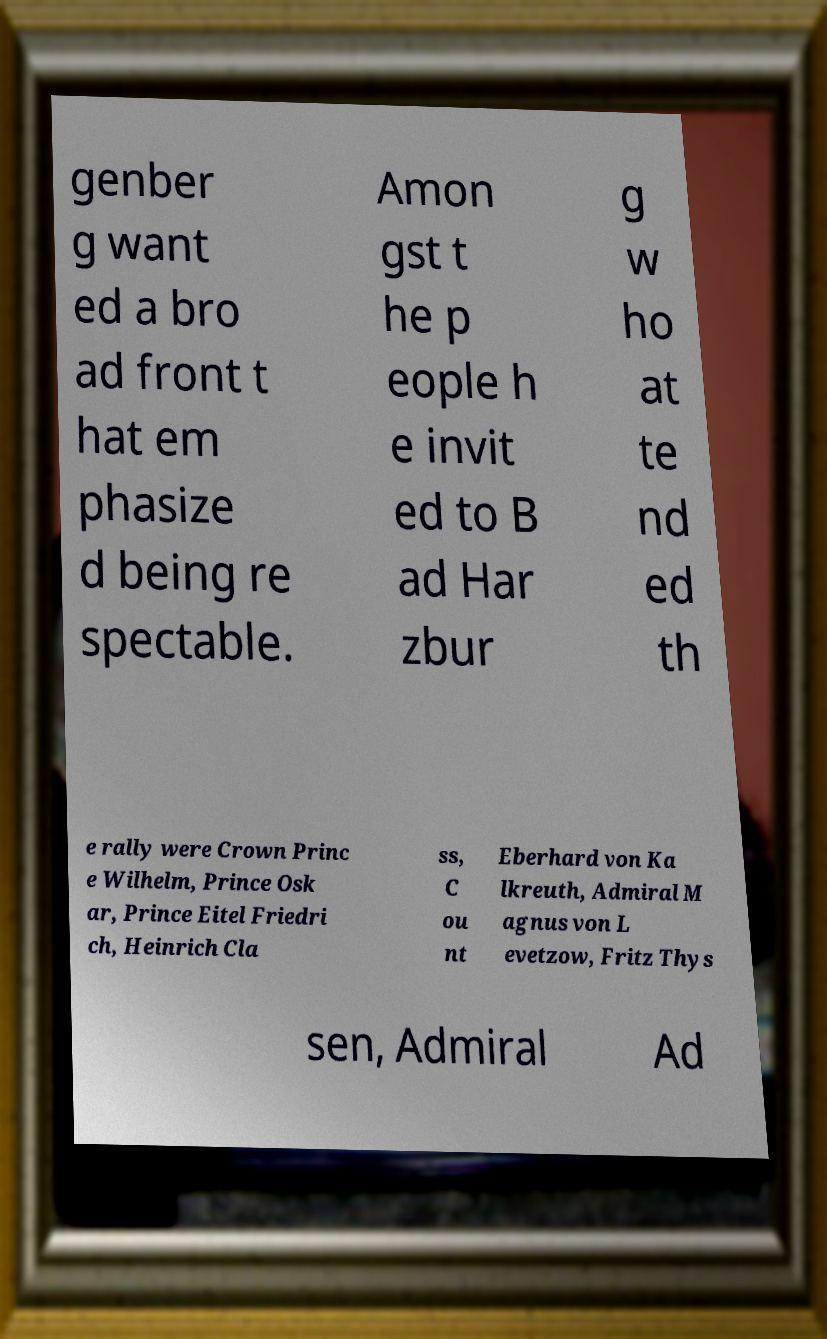Could you extract and type out the text from this image? genber g want ed a bro ad front t hat em phasize d being re spectable. Amon gst t he p eople h e invit ed to B ad Har zbur g w ho at te nd ed th e rally were Crown Princ e Wilhelm, Prince Osk ar, Prince Eitel Friedri ch, Heinrich Cla ss, C ou nt Eberhard von Ka lkreuth, Admiral M agnus von L evetzow, Fritz Thys sen, Admiral Ad 